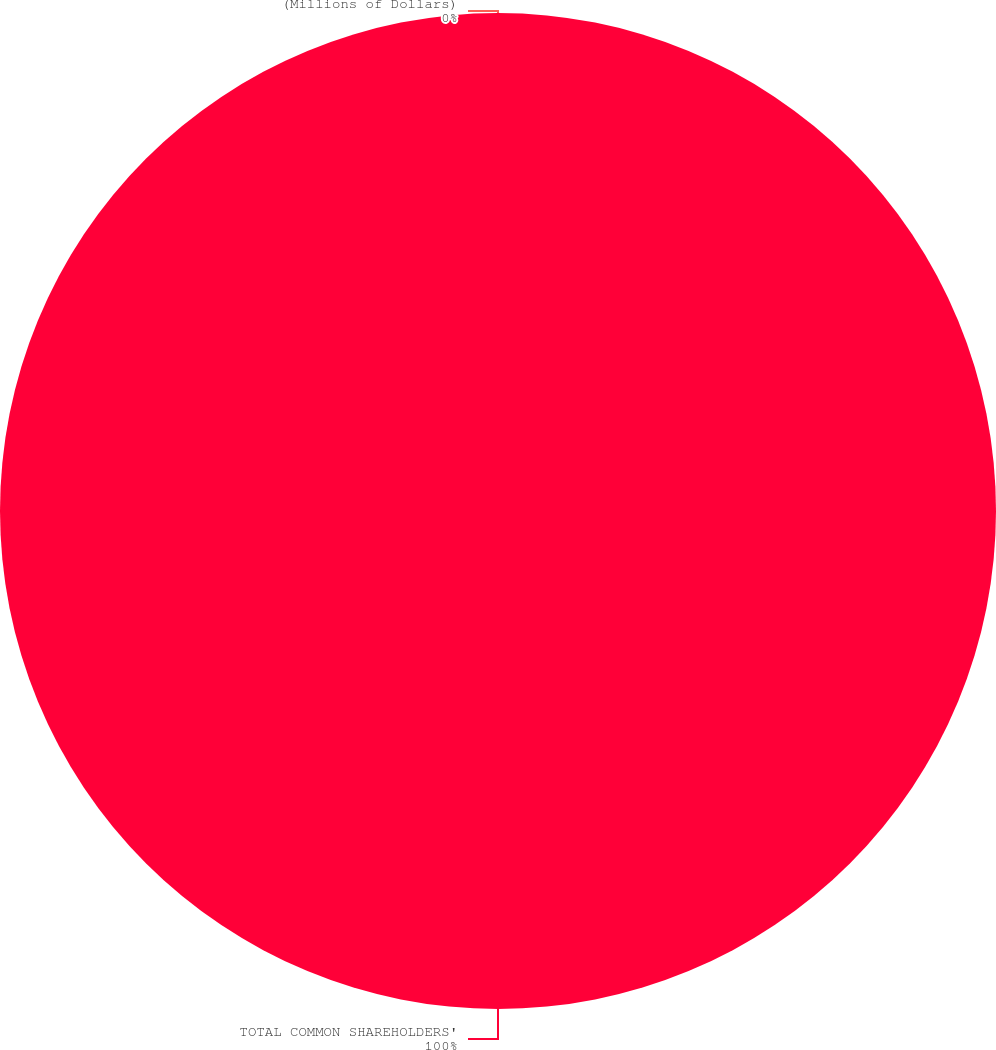<chart> <loc_0><loc_0><loc_500><loc_500><pie_chart><fcel>(Millions of Dollars)<fcel>TOTAL COMMON SHAREHOLDERS'<nl><fcel>0.0%<fcel>100.0%<nl></chart> 